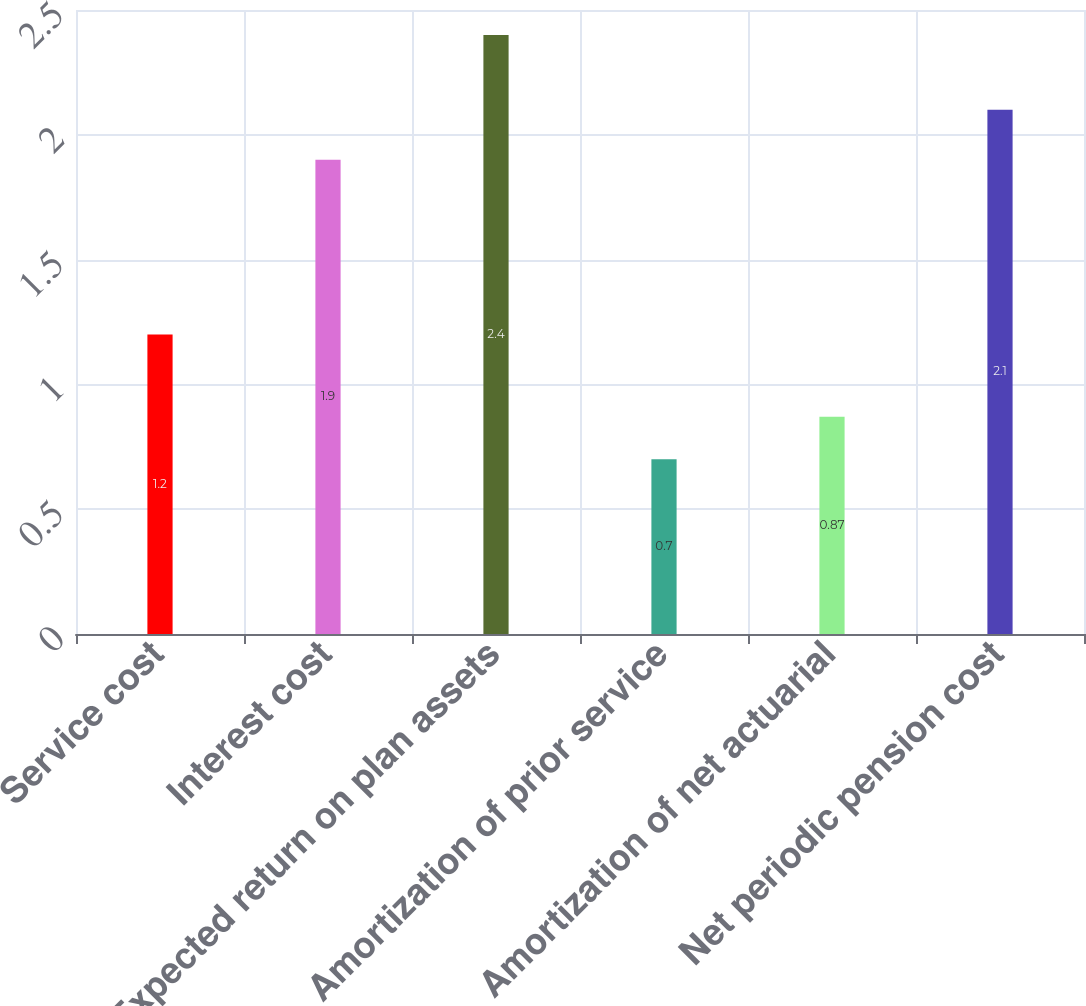Convert chart. <chart><loc_0><loc_0><loc_500><loc_500><bar_chart><fcel>Service cost<fcel>Interest cost<fcel>Expected return on plan assets<fcel>Amortization of prior service<fcel>Amortization of net actuarial<fcel>Net periodic pension cost<nl><fcel>1.2<fcel>1.9<fcel>2.4<fcel>0.7<fcel>0.87<fcel>2.1<nl></chart> 